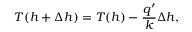Convert formula to latex. <formula><loc_0><loc_0><loc_500><loc_500>T ( h + \Delta h ) = T ( h ) - \frac { q ^ { \prime } } { k } \Delta h ,</formula> 